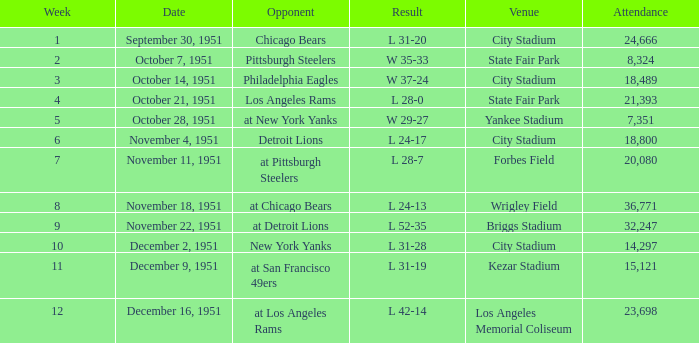Which date's week was more than 4 with the venue being City Stadium and where the attendance was more than 14,297? November 4, 1951. 